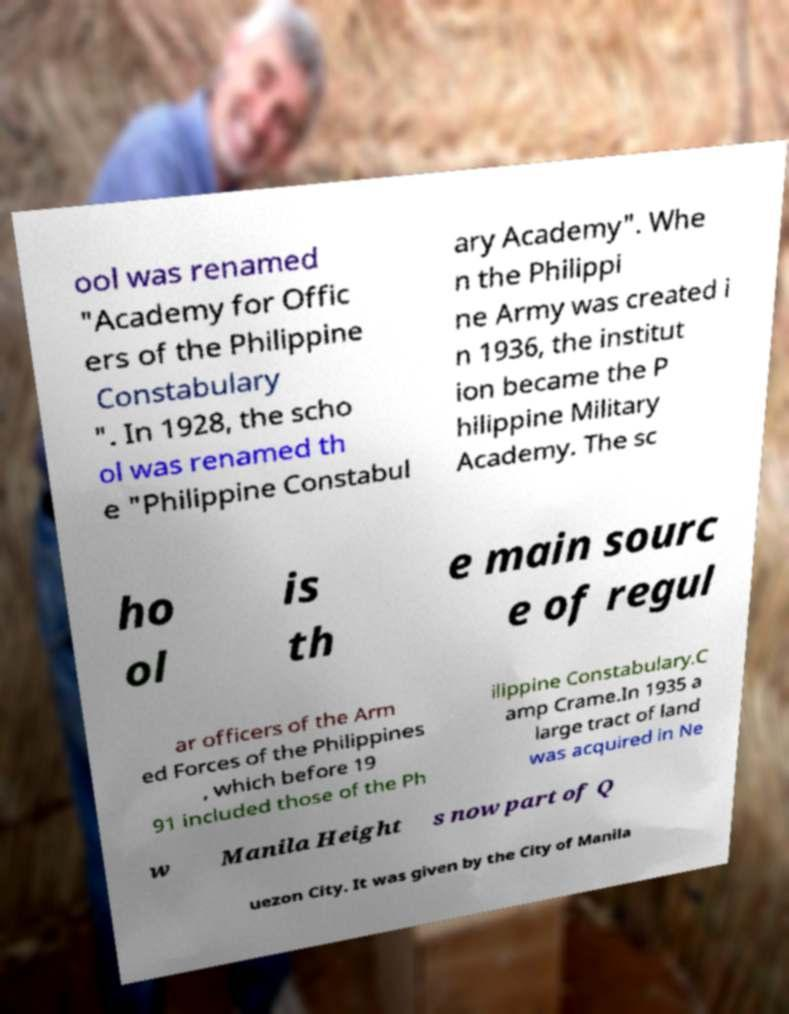For documentation purposes, I need the text within this image transcribed. Could you provide that? ool was renamed "Academy for Offic ers of the Philippine Constabulary ". In 1928, the scho ol was renamed th e "Philippine Constabul ary Academy". Whe n the Philippi ne Army was created i n 1936, the institut ion became the P hilippine Military Academy. The sc ho ol is th e main sourc e of regul ar officers of the Arm ed Forces of the Philippines , which before 19 91 included those of the Ph ilippine Constabulary.C amp Crame.In 1935 a large tract of land was acquired in Ne w Manila Height s now part of Q uezon City. It was given by the City of Manila 